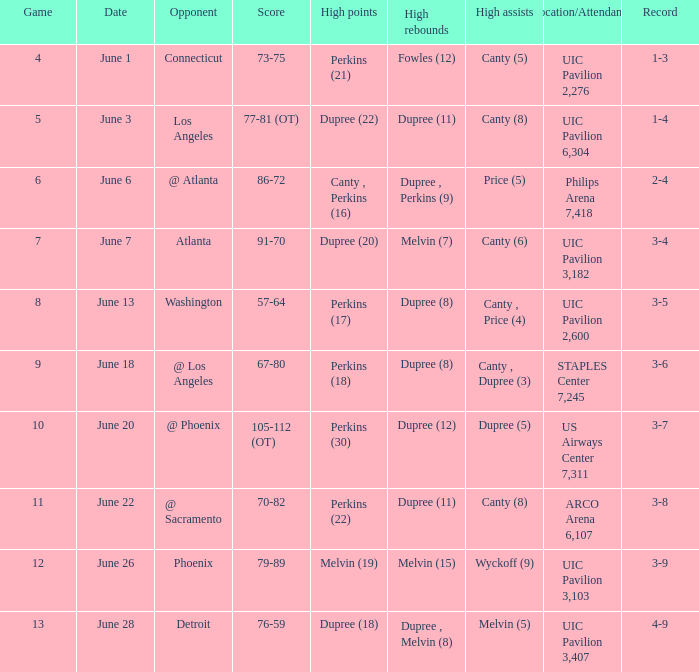Who had the most assists in the game that led to a 3-7 record? Dupree (5). 